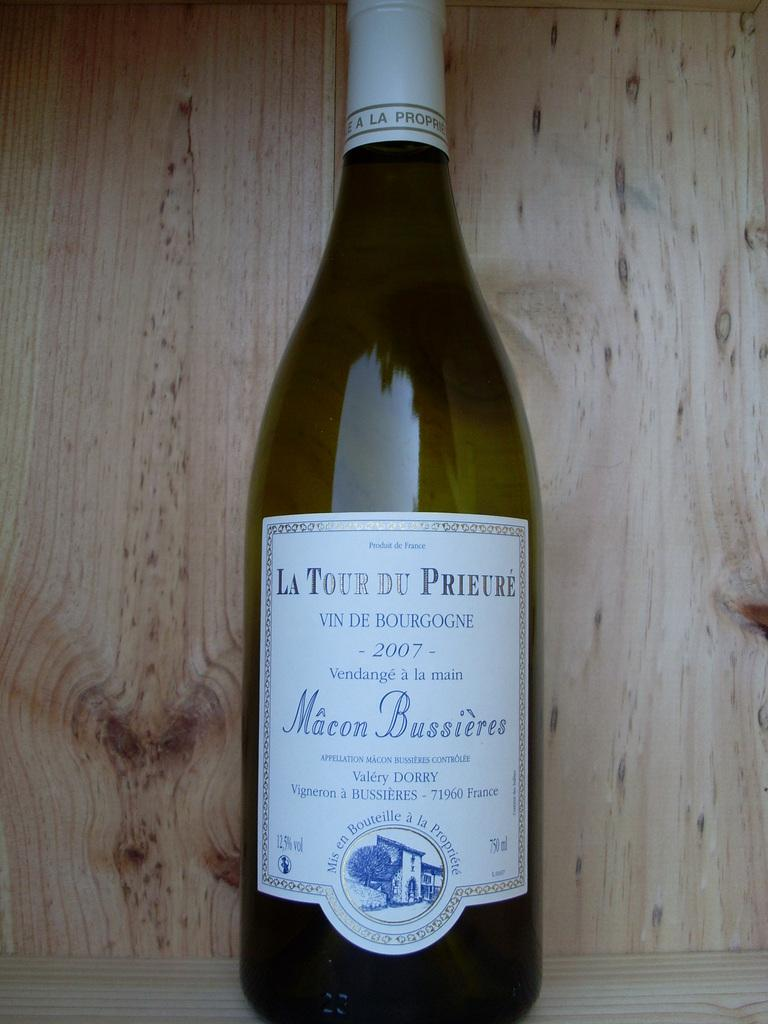What object is present in the image with a label on it? There is a bottle in the image with a label on it. What images can be seen on the label of the bottle? The label contains an image of a tree and a building. What type of background is visible in the image? There is a wooden background in the image. What type of skin can be seen on the glass in the image? There is no glass or skin present in the image; it features a bottle with a label on a wooden background. 